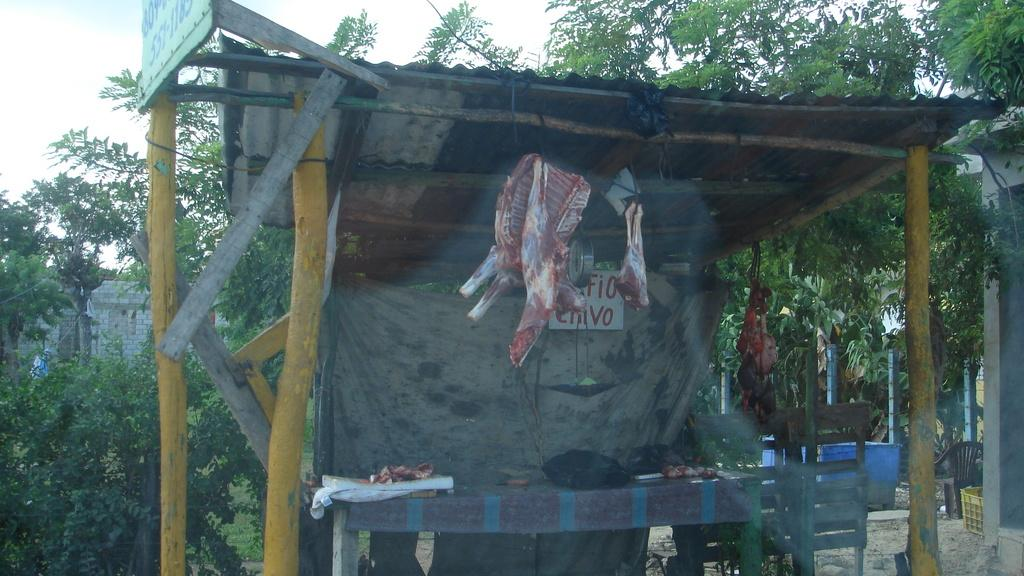What type of establishment is shown in the image? There is a meat shop in the image. What can be seen behind the meat shop? There are trees and buildings behind the meat shop. What structures are visible in the image? There are poles visible in the image. What type of toothbrush is hanging on the pole in the image? There is no toothbrush present in the image; it is a meat shop with poles visible. 